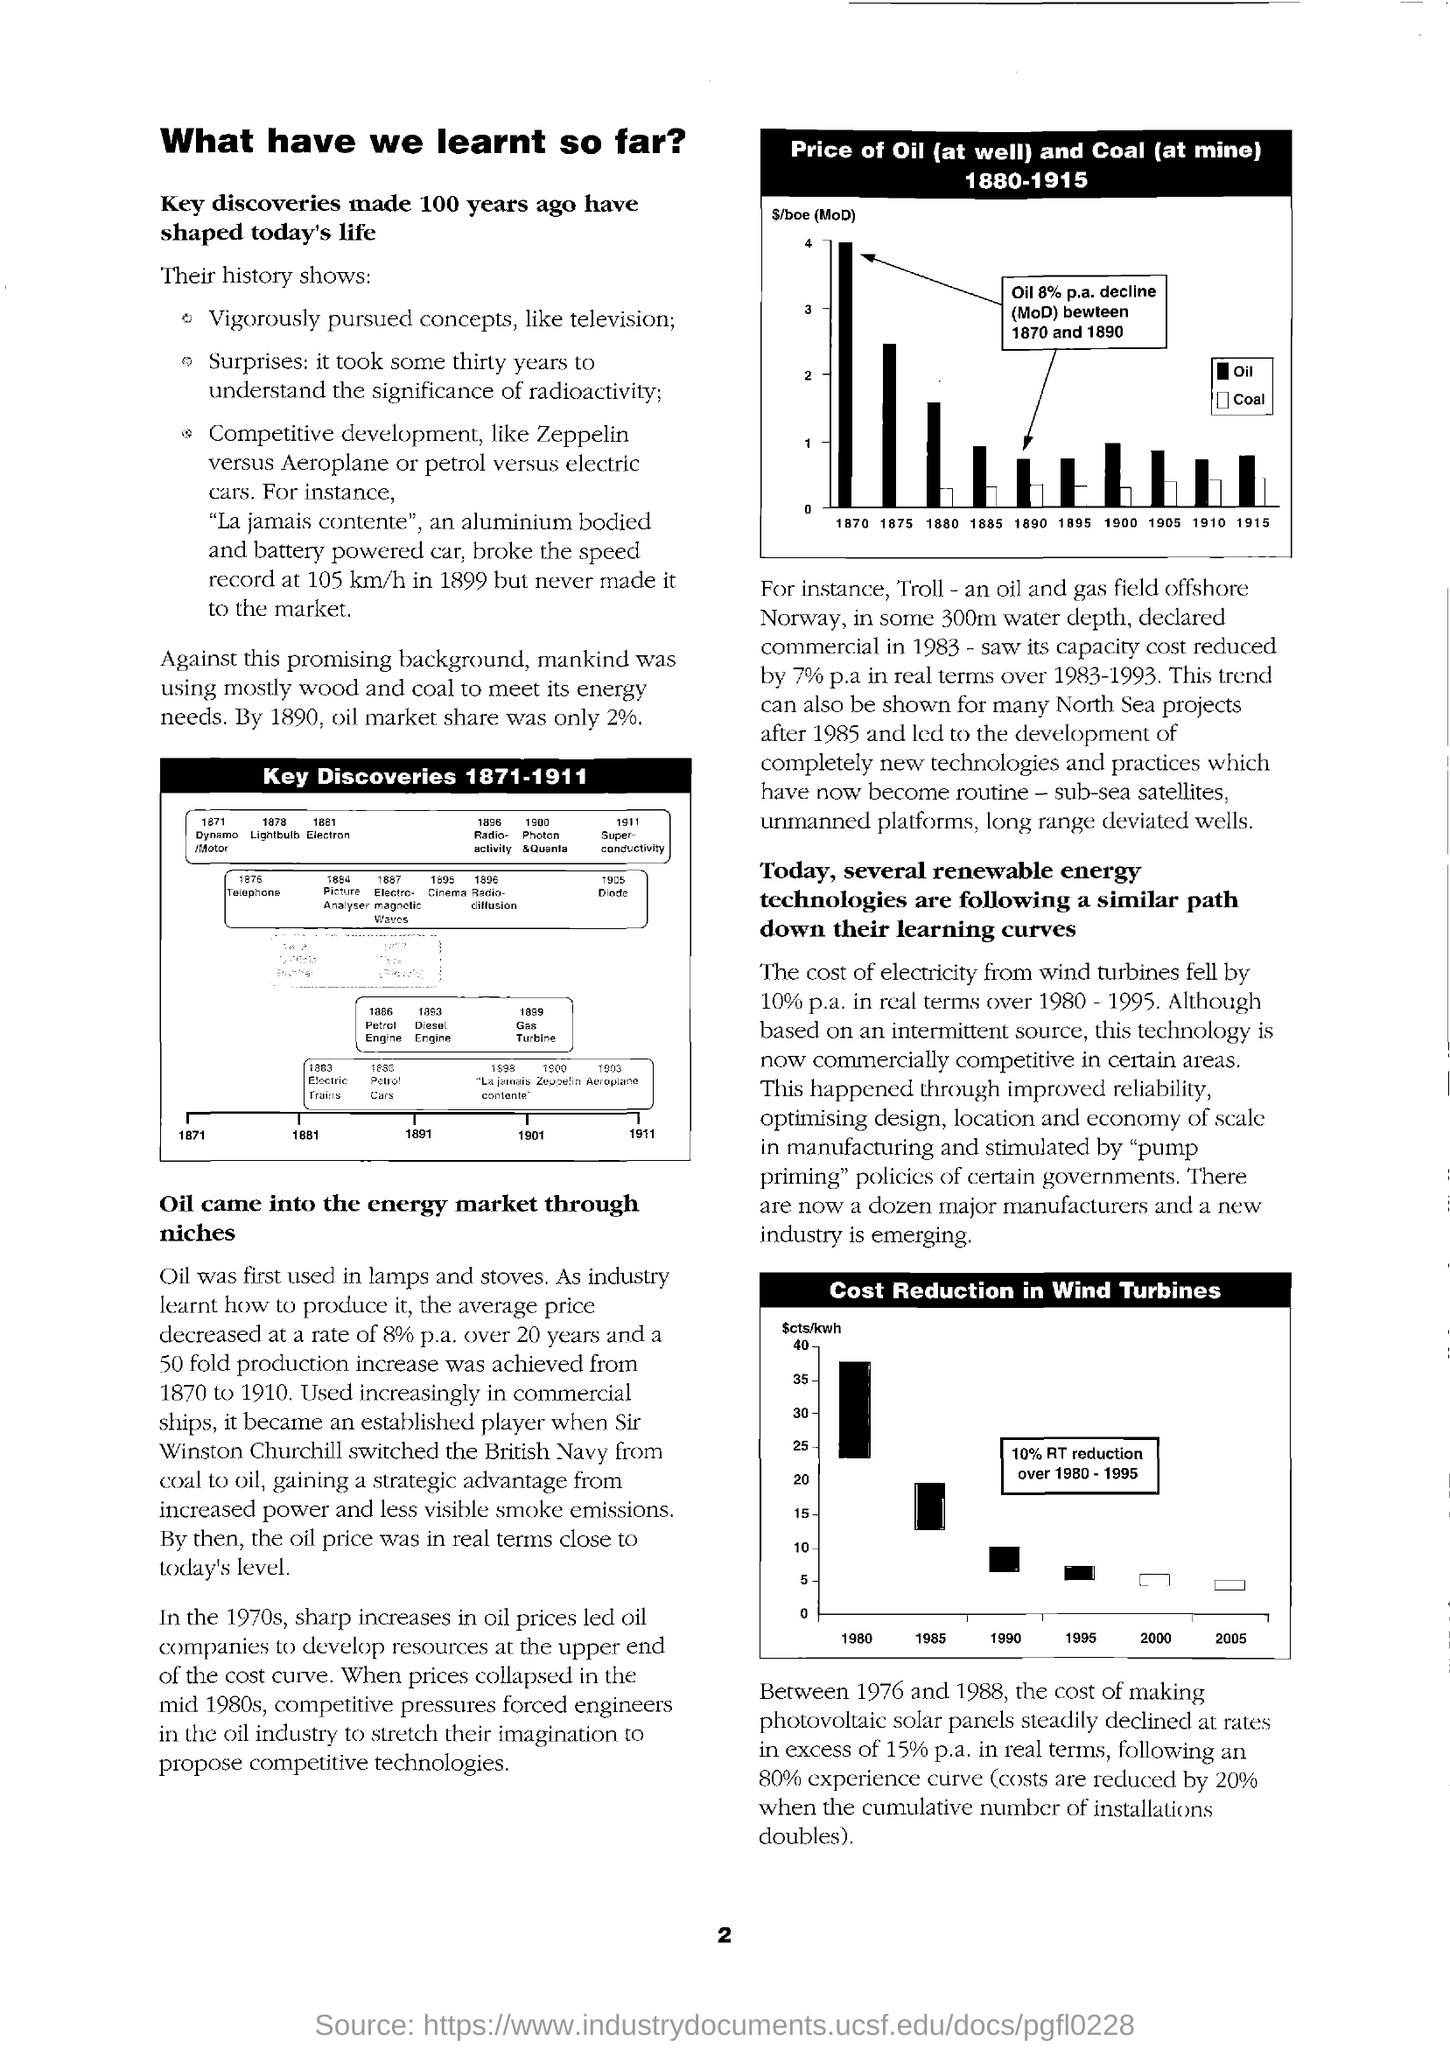Key discoveries made how many years ago shaped today's life?
Keep it short and to the point. 100. By which year oil market shares was only 2 %?
Offer a terse response. 1890. The cost of electricity by wind turbines fell by what percentage  per annual?
Your response must be concise. 10%. 